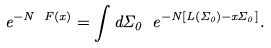Convert formula to latex. <formula><loc_0><loc_0><loc_500><loc_500>e ^ { - N \ F ( x ) } = \int d \Sigma _ { 0 } \ e ^ { - N [ L ( \Sigma _ { 0 } ) - x \Sigma _ { 0 } ] } .</formula> 